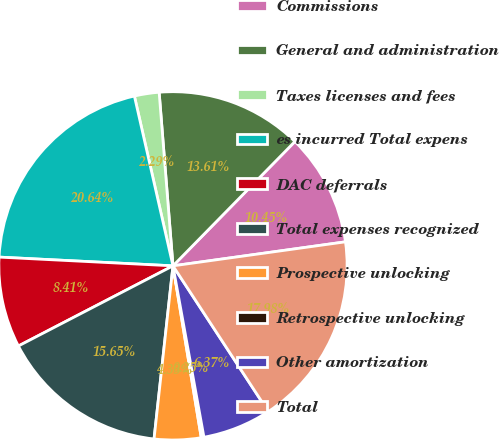Convert chart. <chart><loc_0><loc_0><loc_500><loc_500><pie_chart><fcel>Commissions<fcel>General and administration<fcel>Taxes licenses and fees<fcel>es incurred Total expens<fcel>DAC deferrals<fcel>Total expenses recognized<fcel>Prospective unlocking<fcel>Retrospective unlocking<fcel>Other amortization<fcel>Total<nl><fcel>10.45%<fcel>13.61%<fcel>2.29%<fcel>20.64%<fcel>8.41%<fcel>15.65%<fcel>4.33%<fcel>0.25%<fcel>6.37%<fcel>17.98%<nl></chart> 